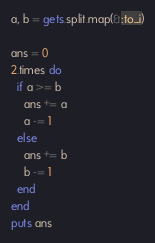<code> <loc_0><loc_0><loc_500><loc_500><_Ruby_>a, b = gets.split.map(&:to_i)

ans = 0
2.times do
  if a >= b
    ans += a
    a -= 1
  else
    ans += b
    b -= 1
  end
end
puts ans</code> 